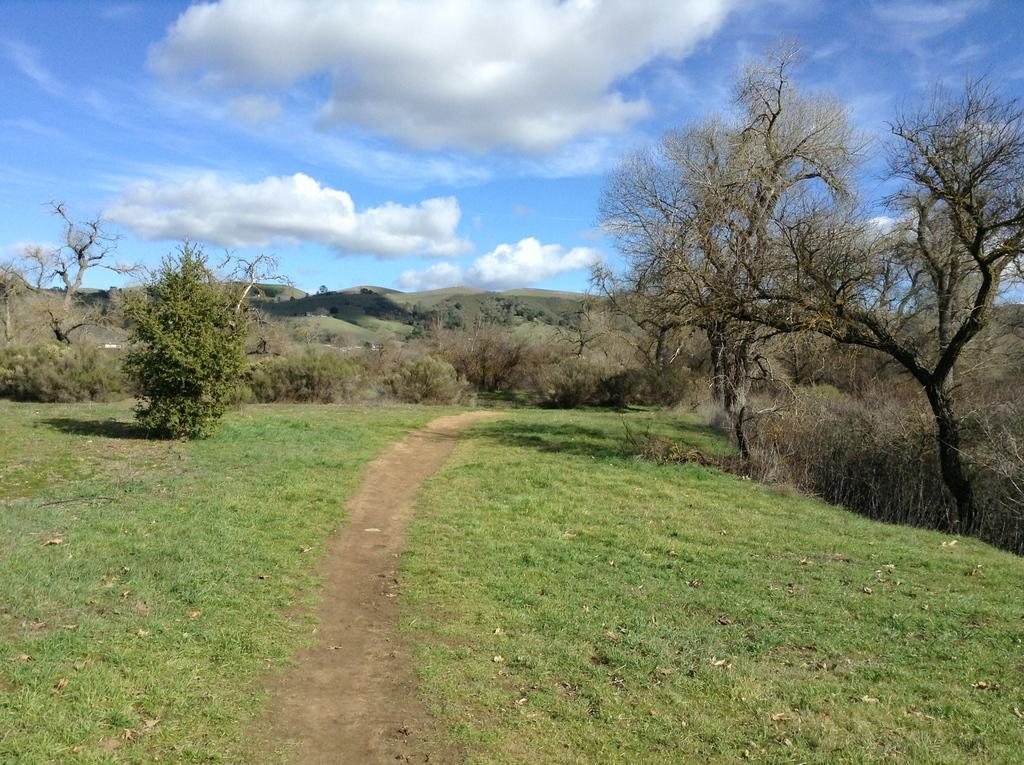What type of vegetation can be seen in the image? There is grass in the image. What can be used for walking or traveling in the image? There is a path in the image. What type of natural structures are visible in the image? There are trees and mountains in the image. What is visible in the background of the image? The sky is visible in the background of the image. What can be seen in the sky in the image? Clouds are present in the sky. What type of hair can be seen on the trees in the image? There is no hair present on the trees in the image; they have leaves or needles, depending on the type of tree. What type of toys can be seen in the image? There are no toys present in the image. 